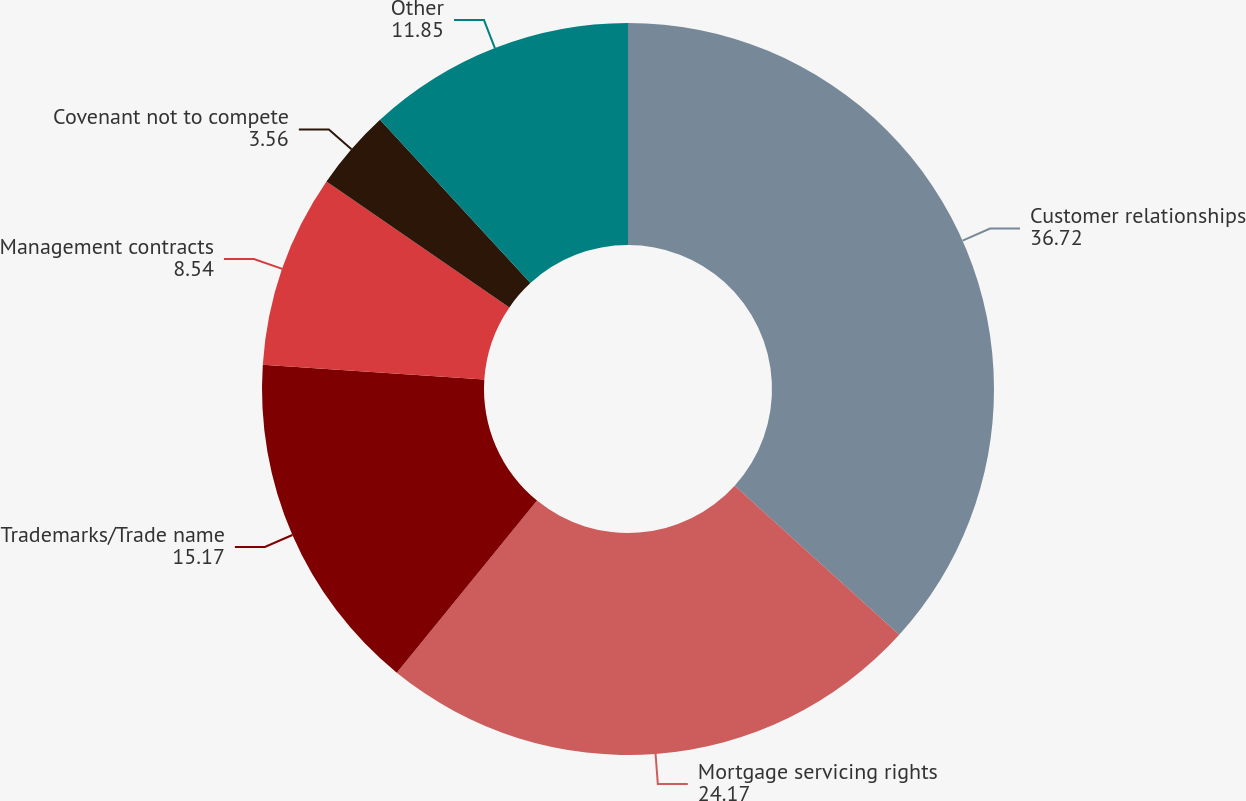<chart> <loc_0><loc_0><loc_500><loc_500><pie_chart><fcel>Customer relationships<fcel>Mortgage servicing rights<fcel>Trademarks/Trade name<fcel>Management contracts<fcel>Covenant not to compete<fcel>Other<nl><fcel>36.72%<fcel>24.17%<fcel>15.17%<fcel>8.54%<fcel>3.56%<fcel>11.85%<nl></chart> 